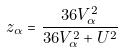Convert formula to latex. <formula><loc_0><loc_0><loc_500><loc_500>z _ { \alpha } = \frac { 3 6 V _ { \alpha } ^ { 2 } } { 3 6 V _ { \alpha } ^ { 2 } + U ^ { 2 } }</formula> 